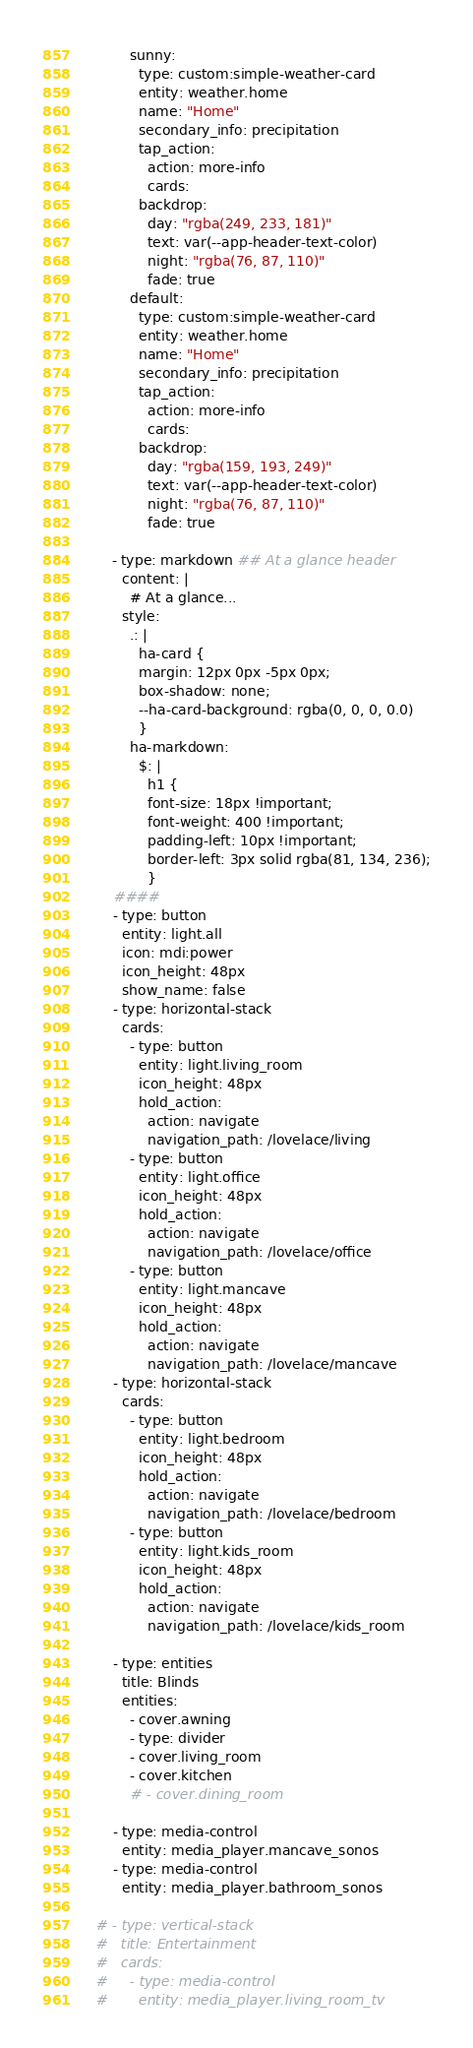<code> <loc_0><loc_0><loc_500><loc_500><_YAML_>            sunny:
              type: custom:simple-weather-card
              entity: weather.home
              name: "Home"
              secondary_info: precipitation
              tap_action:
                action: more-info
                cards:
              backdrop:
                day: "rgba(249, 233, 181)"
                text: var(--app-header-text-color)
                night: "rgba(76, 87, 110)"
                fade: true
            default:
              type: custom:simple-weather-card
              entity: weather.home
              name: "Home"
              secondary_info: precipitation
              tap_action:
                action: more-info
                cards:
              backdrop:
                day: "rgba(159, 193, 249)"
                text: var(--app-header-text-color)
                night: "rgba(76, 87, 110)"
                fade: true

        - type: markdown ## At a glance header
          content: |
            # At a glance...
          style:
            .: |
              ha-card {
              margin: 12px 0px -5px 0px;
              box-shadow: none;
              --ha-card-background: rgba(0, 0, 0, 0.0)
              }
            ha-markdown:
              $: |
                h1 { 
                font-size: 18px !important;
                font-weight: 400 !important;
                padding-left: 10px !important;
                border-left: 3px solid rgba(81, 134, 236);
                }
        ####
        - type: button
          entity: light.all
          icon: mdi:power
          icon_height: 48px
          show_name: false
        - type: horizontal-stack
          cards:
            - type: button
              entity: light.living_room
              icon_height: 48px
              hold_action:
                action: navigate
                navigation_path: /lovelace/living
            - type: button
              entity: light.office
              icon_height: 48px
              hold_action:
                action: navigate
                navigation_path: /lovelace/office
            - type: button
              entity: light.mancave
              icon_height: 48px
              hold_action:
                action: navigate
                navigation_path: /lovelace/mancave
        - type: horizontal-stack
          cards:
            - type: button
              entity: light.bedroom
              icon_height: 48px
              hold_action:
                action: navigate
                navigation_path: /lovelace/bedroom
            - type: button
              entity: light.kids_room
              icon_height: 48px
              hold_action:
                action: navigate
                navigation_path: /lovelace/kids_room

        - type: entities
          title: Blinds
          entities:
            - cover.awning
            - type: divider
            - cover.living_room
            - cover.kitchen
            # - cover.dining_room

        - type: media-control
          entity: media_player.mancave_sonos
        - type: media-control
          entity: media_player.bathroom_sonos

    # - type: vertical-stack
    #   title: Entertainment
    #   cards:
    #     - type: media-control
    #       entity: media_player.living_room_tv</code> 